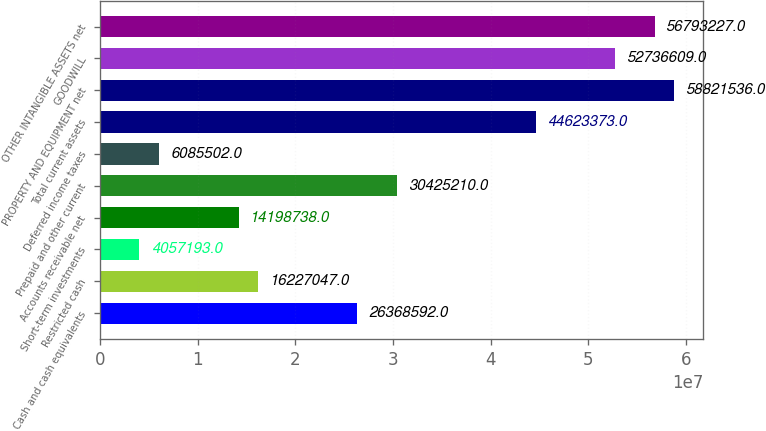Convert chart. <chart><loc_0><loc_0><loc_500><loc_500><bar_chart><fcel>Cash and cash equivalents<fcel>Restricted cash<fcel>Short-term investments<fcel>Accounts receivable net<fcel>Prepaid and other current<fcel>Deferred income taxes<fcel>Total current assets<fcel>PROPERTY AND EQUIPMENT net<fcel>GOODWILL<fcel>OTHER INTANGIBLE ASSETS net<nl><fcel>2.63686e+07<fcel>1.6227e+07<fcel>4.05719e+06<fcel>1.41987e+07<fcel>3.04252e+07<fcel>6.0855e+06<fcel>4.46234e+07<fcel>5.88215e+07<fcel>5.27366e+07<fcel>5.67932e+07<nl></chart> 